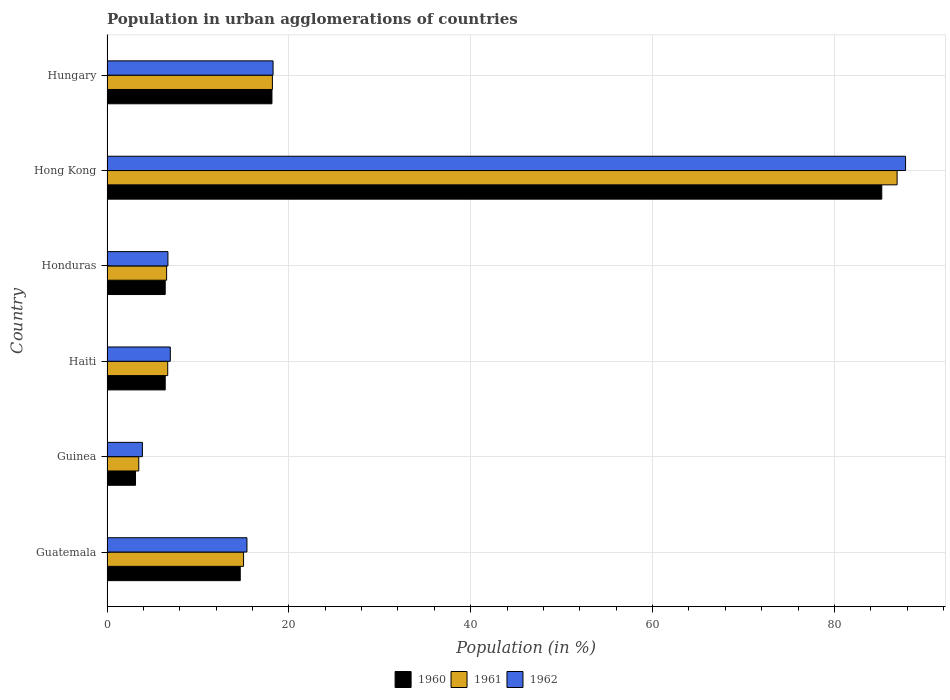How many different coloured bars are there?
Your answer should be compact. 3. Are the number of bars per tick equal to the number of legend labels?
Ensure brevity in your answer.  Yes. How many bars are there on the 6th tick from the top?
Your response must be concise. 3. How many bars are there on the 5th tick from the bottom?
Your answer should be very brief. 3. What is the label of the 1st group of bars from the top?
Provide a short and direct response. Hungary. In how many cases, is the number of bars for a given country not equal to the number of legend labels?
Offer a very short reply. 0. What is the percentage of population in urban agglomerations in 1962 in Guatemala?
Offer a very short reply. 15.39. Across all countries, what is the maximum percentage of population in urban agglomerations in 1960?
Offer a terse response. 85.2. Across all countries, what is the minimum percentage of population in urban agglomerations in 1960?
Make the answer very short. 3.14. In which country was the percentage of population in urban agglomerations in 1961 maximum?
Your answer should be very brief. Hong Kong. In which country was the percentage of population in urban agglomerations in 1962 minimum?
Ensure brevity in your answer.  Guinea. What is the total percentage of population in urban agglomerations in 1960 in the graph?
Your response must be concise. 133.93. What is the difference between the percentage of population in urban agglomerations in 1960 in Guinea and that in Hong Kong?
Ensure brevity in your answer.  -82.07. What is the difference between the percentage of population in urban agglomerations in 1962 in Honduras and the percentage of population in urban agglomerations in 1960 in Haiti?
Provide a short and direct response. 0.3. What is the average percentage of population in urban agglomerations in 1960 per country?
Provide a short and direct response. 22.32. What is the difference between the percentage of population in urban agglomerations in 1962 and percentage of population in urban agglomerations in 1961 in Honduras?
Provide a succinct answer. 0.15. In how many countries, is the percentage of population in urban agglomerations in 1961 greater than 76 %?
Offer a terse response. 1. What is the ratio of the percentage of population in urban agglomerations in 1962 in Guinea to that in Honduras?
Provide a short and direct response. 0.58. What is the difference between the highest and the second highest percentage of population in urban agglomerations in 1961?
Provide a succinct answer. 68.7. What is the difference between the highest and the lowest percentage of population in urban agglomerations in 1962?
Offer a very short reply. 83.93. In how many countries, is the percentage of population in urban agglomerations in 1961 greater than the average percentage of population in urban agglomerations in 1961 taken over all countries?
Your answer should be very brief. 1. What does the 3rd bar from the top in Guinea represents?
Keep it short and to the point. 1960. What does the 2nd bar from the bottom in Hong Kong represents?
Provide a short and direct response. 1961. Is it the case that in every country, the sum of the percentage of population in urban agglomerations in 1960 and percentage of population in urban agglomerations in 1962 is greater than the percentage of population in urban agglomerations in 1961?
Keep it short and to the point. Yes. How many bars are there?
Your answer should be very brief. 18. Are all the bars in the graph horizontal?
Provide a succinct answer. Yes. Are the values on the major ticks of X-axis written in scientific E-notation?
Provide a short and direct response. No. Does the graph contain any zero values?
Offer a terse response. No. Does the graph contain grids?
Keep it short and to the point. Yes. How are the legend labels stacked?
Provide a succinct answer. Horizontal. What is the title of the graph?
Provide a succinct answer. Population in urban agglomerations of countries. What is the label or title of the X-axis?
Make the answer very short. Population (in %). What is the label or title of the Y-axis?
Offer a terse response. Country. What is the Population (in %) of 1960 in Guatemala?
Your answer should be compact. 14.65. What is the Population (in %) in 1961 in Guatemala?
Your answer should be compact. 15.02. What is the Population (in %) of 1962 in Guatemala?
Your answer should be very brief. 15.39. What is the Population (in %) of 1960 in Guinea?
Give a very brief answer. 3.14. What is the Population (in %) in 1961 in Guinea?
Make the answer very short. 3.49. What is the Population (in %) in 1962 in Guinea?
Ensure brevity in your answer.  3.89. What is the Population (in %) in 1960 in Haiti?
Ensure brevity in your answer.  6.4. What is the Population (in %) of 1961 in Haiti?
Offer a very short reply. 6.68. What is the Population (in %) in 1962 in Haiti?
Your answer should be very brief. 6.96. What is the Population (in %) in 1960 in Honduras?
Your response must be concise. 6.4. What is the Population (in %) of 1961 in Honduras?
Give a very brief answer. 6.55. What is the Population (in %) of 1962 in Honduras?
Keep it short and to the point. 6.7. What is the Population (in %) of 1960 in Hong Kong?
Make the answer very short. 85.2. What is the Population (in %) in 1961 in Hong Kong?
Give a very brief answer. 86.89. What is the Population (in %) of 1962 in Hong Kong?
Provide a succinct answer. 87.82. What is the Population (in %) of 1960 in Hungary?
Your answer should be compact. 18.14. What is the Population (in %) of 1961 in Hungary?
Make the answer very short. 18.19. What is the Population (in %) in 1962 in Hungary?
Offer a very short reply. 18.26. Across all countries, what is the maximum Population (in %) of 1960?
Ensure brevity in your answer.  85.2. Across all countries, what is the maximum Population (in %) of 1961?
Your answer should be very brief. 86.89. Across all countries, what is the maximum Population (in %) of 1962?
Offer a very short reply. 87.82. Across all countries, what is the minimum Population (in %) of 1960?
Your answer should be compact. 3.14. Across all countries, what is the minimum Population (in %) in 1961?
Make the answer very short. 3.49. Across all countries, what is the minimum Population (in %) of 1962?
Give a very brief answer. 3.89. What is the total Population (in %) in 1960 in the graph?
Make the answer very short. 133.93. What is the total Population (in %) in 1961 in the graph?
Your answer should be compact. 136.82. What is the total Population (in %) in 1962 in the graph?
Keep it short and to the point. 139.03. What is the difference between the Population (in %) of 1960 in Guatemala and that in Guinea?
Provide a succinct answer. 11.52. What is the difference between the Population (in %) in 1961 in Guatemala and that in Guinea?
Your answer should be compact. 11.52. What is the difference between the Population (in %) in 1962 in Guatemala and that in Guinea?
Ensure brevity in your answer.  11.49. What is the difference between the Population (in %) in 1960 in Guatemala and that in Haiti?
Make the answer very short. 8.25. What is the difference between the Population (in %) in 1961 in Guatemala and that in Haiti?
Ensure brevity in your answer.  8.34. What is the difference between the Population (in %) in 1962 in Guatemala and that in Haiti?
Offer a terse response. 8.43. What is the difference between the Population (in %) in 1960 in Guatemala and that in Honduras?
Offer a very short reply. 8.25. What is the difference between the Population (in %) of 1961 in Guatemala and that in Honduras?
Provide a succinct answer. 8.46. What is the difference between the Population (in %) of 1962 in Guatemala and that in Honduras?
Provide a short and direct response. 8.69. What is the difference between the Population (in %) of 1960 in Guatemala and that in Hong Kong?
Make the answer very short. -70.55. What is the difference between the Population (in %) in 1961 in Guatemala and that in Hong Kong?
Give a very brief answer. -71.87. What is the difference between the Population (in %) of 1962 in Guatemala and that in Hong Kong?
Ensure brevity in your answer.  -72.43. What is the difference between the Population (in %) in 1960 in Guatemala and that in Hungary?
Keep it short and to the point. -3.49. What is the difference between the Population (in %) in 1961 in Guatemala and that in Hungary?
Ensure brevity in your answer.  -3.17. What is the difference between the Population (in %) in 1962 in Guatemala and that in Hungary?
Your answer should be compact. -2.87. What is the difference between the Population (in %) in 1960 in Guinea and that in Haiti?
Your answer should be compact. -3.27. What is the difference between the Population (in %) of 1961 in Guinea and that in Haiti?
Keep it short and to the point. -3.18. What is the difference between the Population (in %) of 1962 in Guinea and that in Haiti?
Your answer should be compact. -3.07. What is the difference between the Population (in %) in 1960 in Guinea and that in Honduras?
Offer a terse response. -3.27. What is the difference between the Population (in %) of 1961 in Guinea and that in Honduras?
Your response must be concise. -3.06. What is the difference between the Population (in %) in 1962 in Guinea and that in Honduras?
Provide a succinct answer. -2.81. What is the difference between the Population (in %) in 1960 in Guinea and that in Hong Kong?
Provide a short and direct response. -82.07. What is the difference between the Population (in %) in 1961 in Guinea and that in Hong Kong?
Offer a very short reply. -83.4. What is the difference between the Population (in %) of 1962 in Guinea and that in Hong Kong?
Provide a short and direct response. -83.93. What is the difference between the Population (in %) in 1960 in Guinea and that in Hungary?
Give a very brief answer. -15.01. What is the difference between the Population (in %) of 1961 in Guinea and that in Hungary?
Provide a short and direct response. -14.7. What is the difference between the Population (in %) in 1962 in Guinea and that in Hungary?
Your response must be concise. -14.37. What is the difference between the Population (in %) in 1960 in Haiti and that in Honduras?
Your answer should be compact. 0. What is the difference between the Population (in %) of 1961 in Haiti and that in Honduras?
Make the answer very short. 0.12. What is the difference between the Population (in %) of 1962 in Haiti and that in Honduras?
Keep it short and to the point. 0.26. What is the difference between the Population (in %) of 1960 in Haiti and that in Hong Kong?
Offer a very short reply. -78.8. What is the difference between the Population (in %) in 1961 in Haiti and that in Hong Kong?
Offer a terse response. -80.21. What is the difference between the Population (in %) in 1962 in Haiti and that in Hong Kong?
Give a very brief answer. -80.86. What is the difference between the Population (in %) in 1960 in Haiti and that in Hungary?
Provide a succinct answer. -11.74. What is the difference between the Population (in %) in 1961 in Haiti and that in Hungary?
Offer a terse response. -11.51. What is the difference between the Population (in %) in 1962 in Haiti and that in Hungary?
Provide a short and direct response. -11.3. What is the difference between the Population (in %) of 1960 in Honduras and that in Hong Kong?
Ensure brevity in your answer.  -78.8. What is the difference between the Population (in %) of 1961 in Honduras and that in Hong Kong?
Offer a terse response. -80.34. What is the difference between the Population (in %) of 1962 in Honduras and that in Hong Kong?
Give a very brief answer. -81.12. What is the difference between the Population (in %) of 1960 in Honduras and that in Hungary?
Make the answer very short. -11.74. What is the difference between the Population (in %) of 1961 in Honduras and that in Hungary?
Your response must be concise. -11.64. What is the difference between the Population (in %) in 1962 in Honduras and that in Hungary?
Give a very brief answer. -11.56. What is the difference between the Population (in %) of 1960 in Hong Kong and that in Hungary?
Offer a very short reply. 67.06. What is the difference between the Population (in %) in 1961 in Hong Kong and that in Hungary?
Your answer should be compact. 68.7. What is the difference between the Population (in %) of 1962 in Hong Kong and that in Hungary?
Ensure brevity in your answer.  69.56. What is the difference between the Population (in %) in 1960 in Guatemala and the Population (in %) in 1961 in Guinea?
Offer a very short reply. 11.16. What is the difference between the Population (in %) in 1960 in Guatemala and the Population (in %) in 1962 in Guinea?
Give a very brief answer. 10.76. What is the difference between the Population (in %) of 1961 in Guatemala and the Population (in %) of 1962 in Guinea?
Provide a succinct answer. 11.12. What is the difference between the Population (in %) of 1960 in Guatemala and the Population (in %) of 1961 in Haiti?
Your response must be concise. 7.98. What is the difference between the Population (in %) in 1960 in Guatemala and the Population (in %) in 1962 in Haiti?
Give a very brief answer. 7.69. What is the difference between the Population (in %) of 1961 in Guatemala and the Population (in %) of 1962 in Haiti?
Provide a succinct answer. 8.05. What is the difference between the Population (in %) of 1960 in Guatemala and the Population (in %) of 1961 in Honduras?
Your response must be concise. 8.1. What is the difference between the Population (in %) in 1960 in Guatemala and the Population (in %) in 1962 in Honduras?
Give a very brief answer. 7.95. What is the difference between the Population (in %) of 1961 in Guatemala and the Population (in %) of 1962 in Honduras?
Provide a short and direct response. 8.32. What is the difference between the Population (in %) in 1960 in Guatemala and the Population (in %) in 1961 in Hong Kong?
Offer a very short reply. -72.24. What is the difference between the Population (in %) in 1960 in Guatemala and the Population (in %) in 1962 in Hong Kong?
Keep it short and to the point. -73.17. What is the difference between the Population (in %) of 1961 in Guatemala and the Population (in %) of 1962 in Hong Kong?
Give a very brief answer. -72.8. What is the difference between the Population (in %) in 1960 in Guatemala and the Population (in %) in 1961 in Hungary?
Your response must be concise. -3.54. What is the difference between the Population (in %) of 1960 in Guatemala and the Population (in %) of 1962 in Hungary?
Your answer should be compact. -3.61. What is the difference between the Population (in %) in 1961 in Guatemala and the Population (in %) in 1962 in Hungary?
Keep it short and to the point. -3.25. What is the difference between the Population (in %) of 1960 in Guinea and the Population (in %) of 1961 in Haiti?
Make the answer very short. -3.54. What is the difference between the Population (in %) in 1960 in Guinea and the Population (in %) in 1962 in Haiti?
Provide a succinct answer. -3.83. What is the difference between the Population (in %) in 1961 in Guinea and the Population (in %) in 1962 in Haiti?
Keep it short and to the point. -3.47. What is the difference between the Population (in %) of 1960 in Guinea and the Population (in %) of 1961 in Honduras?
Offer a very short reply. -3.42. What is the difference between the Population (in %) of 1960 in Guinea and the Population (in %) of 1962 in Honduras?
Give a very brief answer. -3.57. What is the difference between the Population (in %) of 1961 in Guinea and the Population (in %) of 1962 in Honduras?
Give a very brief answer. -3.21. What is the difference between the Population (in %) in 1960 in Guinea and the Population (in %) in 1961 in Hong Kong?
Provide a short and direct response. -83.75. What is the difference between the Population (in %) of 1960 in Guinea and the Population (in %) of 1962 in Hong Kong?
Provide a succinct answer. -84.68. What is the difference between the Population (in %) of 1961 in Guinea and the Population (in %) of 1962 in Hong Kong?
Your answer should be compact. -84.33. What is the difference between the Population (in %) of 1960 in Guinea and the Population (in %) of 1961 in Hungary?
Give a very brief answer. -15.05. What is the difference between the Population (in %) in 1960 in Guinea and the Population (in %) in 1962 in Hungary?
Your answer should be compact. -15.13. What is the difference between the Population (in %) of 1961 in Guinea and the Population (in %) of 1962 in Hungary?
Ensure brevity in your answer.  -14.77. What is the difference between the Population (in %) in 1960 in Haiti and the Population (in %) in 1961 in Honduras?
Provide a succinct answer. -0.15. What is the difference between the Population (in %) in 1960 in Haiti and the Population (in %) in 1962 in Honduras?
Ensure brevity in your answer.  -0.3. What is the difference between the Population (in %) of 1961 in Haiti and the Population (in %) of 1962 in Honduras?
Offer a very short reply. -0.02. What is the difference between the Population (in %) of 1960 in Haiti and the Population (in %) of 1961 in Hong Kong?
Keep it short and to the point. -80.49. What is the difference between the Population (in %) in 1960 in Haiti and the Population (in %) in 1962 in Hong Kong?
Ensure brevity in your answer.  -81.42. What is the difference between the Population (in %) of 1961 in Haiti and the Population (in %) of 1962 in Hong Kong?
Your answer should be compact. -81.14. What is the difference between the Population (in %) in 1960 in Haiti and the Population (in %) in 1961 in Hungary?
Provide a succinct answer. -11.79. What is the difference between the Population (in %) in 1960 in Haiti and the Population (in %) in 1962 in Hungary?
Your answer should be very brief. -11.86. What is the difference between the Population (in %) of 1961 in Haiti and the Population (in %) of 1962 in Hungary?
Ensure brevity in your answer.  -11.59. What is the difference between the Population (in %) of 1960 in Honduras and the Population (in %) of 1961 in Hong Kong?
Your response must be concise. -80.49. What is the difference between the Population (in %) in 1960 in Honduras and the Population (in %) in 1962 in Hong Kong?
Your answer should be very brief. -81.42. What is the difference between the Population (in %) of 1961 in Honduras and the Population (in %) of 1962 in Hong Kong?
Provide a succinct answer. -81.27. What is the difference between the Population (in %) of 1960 in Honduras and the Population (in %) of 1961 in Hungary?
Give a very brief answer. -11.79. What is the difference between the Population (in %) of 1960 in Honduras and the Population (in %) of 1962 in Hungary?
Offer a very short reply. -11.86. What is the difference between the Population (in %) of 1961 in Honduras and the Population (in %) of 1962 in Hungary?
Give a very brief answer. -11.71. What is the difference between the Population (in %) of 1960 in Hong Kong and the Population (in %) of 1961 in Hungary?
Provide a succinct answer. 67.01. What is the difference between the Population (in %) of 1960 in Hong Kong and the Population (in %) of 1962 in Hungary?
Keep it short and to the point. 66.94. What is the difference between the Population (in %) of 1961 in Hong Kong and the Population (in %) of 1962 in Hungary?
Provide a succinct answer. 68.63. What is the average Population (in %) in 1960 per country?
Keep it short and to the point. 22.32. What is the average Population (in %) in 1961 per country?
Make the answer very short. 22.8. What is the average Population (in %) in 1962 per country?
Provide a short and direct response. 23.17. What is the difference between the Population (in %) of 1960 and Population (in %) of 1961 in Guatemala?
Your response must be concise. -0.36. What is the difference between the Population (in %) of 1960 and Population (in %) of 1962 in Guatemala?
Your response must be concise. -0.74. What is the difference between the Population (in %) in 1961 and Population (in %) in 1962 in Guatemala?
Ensure brevity in your answer.  -0.37. What is the difference between the Population (in %) of 1960 and Population (in %) of 1961 in Guinea?
Provide a short and direct response. -0.36. What is the difference between the Population (in %) in 1960 and Population (in %) in 1962 in Guinea?
Give a very brief answer. -0.76. What is the difference between the Population (in %) in 1960 and Population (in %) in 1961 in Haiti?
Ensure brevity in your answer.  -0.27. What is the difference between the Population (in %) in 1960 and Population (in %) in 1962 in Haiti?
Offer a terse response. -0.56. What is the difference between the Population (in %) in 1961 and Population (in %) in 1962 in Haiti?
Make the answer very short. -0.29. What is the difference between the Population (in %) in 1960 and Population (in %) in 1961 in Honduras?
Provide a succinct answer. -0.15. What is the difference between the Population (in %) in 1960 and Population (in %) in 1962 in Honduras?
Provide a succinct answer. -0.3. What is the difference between the Population (in %) of 1961 and Population (in %) of 1962 in Honduras?
Offer a terse response. -0.15. What is the difference between the Population (in %) in 1960 and Population (in %) in 1961 in Hong Kong?
Make the answer very short. -1.69. What is the difference between the Population (in %) of 1960 and Population (in %) of 1962 in Hong Kong?
Provide a short and direct response. -2.62. What is the difference between the Population (in %) of 1961 and Population (in %) of 1962 in Hong Kong?
Give a very brief answer. -0.93. What is the difference between the Population (in %) in 1960 and Population (in %) in 1961 in Hungary?
Ensure brevity in your answer.  -0.05. What is the difference between the Population (in %) in 1960 and Population (in %) in 1962 in Hungary?
Your answer should be very brief. -0.12. What is the difference between the Population (in %) in 1961 and Population (in %) in 1962 in Hungary?
Offer a terse response. -0.07. What is the ratio of the Population (in %) in 1960 in Guatemala to that in Guinea?
Your answer should be compact. 4.67. What is the ratio of the Population (in %) in 1961 in Guatemala to that in Guinea?
Your answer should be compact. 4.3. What is the ratio of the Population (in %) in 1962 in Guatemala to that in Guinea?
Your response must be concise. 3.95. What is the ratio of the Population (in %) in 1960 in Guatemala to that in Haiti?
Provide a succinct answer. 2.29. What is the ratio of the Population (in %) in 1961 in Guatemala to that in Haiti?
Ensure brevity in your answer.  2.25. What is the ratio of the Population (in %) in 1962 in Guatemala to that in Haiti?
Ensure brevity in your answer.  2.21. What is the ratio of the Population (in %) in 1960 in Guatemala to that in Honduras?
Offer a terse response. 2.29. What is the ratio of the Population (in %) in 1961 in Guatemala to that in Honduras?
Provide a succinct answer. 2.29. What is the ratio of the Population (in %) in 1962 in Guatemala to that in Honduras?
Provide a short and direct response. 2.3. What is the ratio of the Population (in %) of 1960 in Guatemala to that in Hong Kong?
Your response must be concise. 0.17. What is the ratio of the Population (in %) of 1961 in Guatemala to that in Hong Kong?
Provide a short and direct response. 0.17. What is the ratio of the Population (in %) in 1962 in Guatemala to that in Hong Kong?
Offer a very short reply. 0.18. What is the ratio of the Population (in %) in 1960 in Guatemala to that in Hungary?
Offer a very short reply. 0.81. What is the ratio of the Population (in %) in 1961 in Guatemala to that in Hungary?
Your answer should be compact. 0.83. What is the ratio of the Population (in %) in 1962 in Guatemala to that in Hungary?
Give a very brief answer. 0.84. What is the ratio of the Population (in %) of 1960 in Guinea to that in Haiti?
Keep it short and to the point. 0.49. What is the ratio of the Population (in %) in 1961 in Guinea to that in Haiti?
Keep it short and to the point. 0.52. What is the ratio of the Population (in %) in 1962 in Guinea to that in Haiti?
Keep it short and to the point. 0.56. What is the ratio of the Population (in %) in 1960 in Guinea to that in Honduras?
Offer a terse response. 0.49. What is the ratio of the Population (in %) of 1961 in Guinea to that in Honduras?
Your answer should be compact. 0.53. What is the ratio of the Population (in %) of 1962 in Guinea to that in Honduras?
Provide a short and direct response. 0.58. What is the ratio of the Population (in %) of 1960 in Guinea to that in Hong Kong?
Your answer should be very brief. 0.04. What is the ratio of the Population (in %) of 1961 in Guinea to that in Hong Kong?
Provide a succinct answer. 0.04. What is the ratio of the Population (in %) in 1962 in Guinea to that in Hong Kong?
Provide a short and direct response. 0.04. What is the ratio of the Population (in %) of 1960 in Guinea to that in Hungary?
Offer a very short reply. 0.17. What is the ratio of the Population (in %) of 1961 in Guinea to that in Hungary?
Your answer should be compact. 0.19. What is the ratio of the Population (in %) of 1962 in Guinea to that in Hungary?
Provide a short and direct response. 0.21. What is the ratio of the Population (in %) of 1961 in Haiti to that in Honduras?
Offer a terse response. 1.02. What is the ratio of the Population (in %) of 1962 in Haiti to that in Honduras?
Your answer should be very brief. 1.04. What is the ratio of the Population (in %) in 1960 in Haiti to that in Hong Kong?
Offer a very short reply. 0.08. What is the ratio of the Population (in %) in 1961 in Haiti to that in Hong Kong?
Ensure brevity in your answer.  0.08. What is the ratio of the Population (in %) in 1962 in Haiti to that in Hong Kong?
Your answer should be very brief. 0.08. What is the ratio of the Population (in %) in 1960 in Haiti to that in Hungary?
Offer a very short reply. 0.35. What is the ratio of the Population (in %) in 1961 in Haiti to that in Hungary?
Offer a terse response. 0.37. What is the ratio of the Population (in %) in 1962 in Haiti to that in Hungary?
Offer a very short reply. 0.38. What is the ratio of the Population (in %) in 1960 in Honduras to that in Hong Kong?
Ensure brevity in your answer.  0.08. What is the ratio of the Population (in %) of 1961 in Honduras to that in Hong Kong?
Your answer should be compact. 0.08. What is the ratio of the Population (in %) of 1962 in Honduras to that in Hong Kong?
Give a very brief answer. 0.08. What is the ratio of the Population (in %) in 1960 in Honduras to that in Hungary?
Provide a succinct answer. 0.35. What is the ratio of the Population (in %) in 1961 in Honduras to that in Hungary?
Make the answer very short. 0.36. What is the ratio of the Population (in %) of 1962 in Honduras to that in Hungary?
Keep it short and to the point. 0.37. What is the ratio of the Population (in %) in 1960 in Hong Kong to that in Hungary?
Offer a very short reply. 4.7. What is the ratio of the Population (in %) in 1961 in Hong Kong to that in Hungary?
Keep it short and to the point. 4.78. What is the ratio of the Population (in %) of 1962 in Hong Kong to that in Hungary?
Make the answer very short. 4.81. What is the difference between the highest and the second highest Population (in %) in 1960?
Make the answer very short. 67.06. What is the difference between the highest and the second highest Population (in %) of 1961?
Give a very brief answer. 68.7. What is the difference between the highest and the second highest Population (in %) in 1962?
Provide a short and direct response. 69.56. What is the difference between the highest and the lowest Population (in %) in 1960?
Your answer should be very brief. 82.07. What is the difference between the highest and the lowest Population (in %) in 1961?
Your answer should be compact. 83.4. What is the difference between the highest and the lowest Population (in %) of 1962?
Keep it short and to the point. 83.93. 